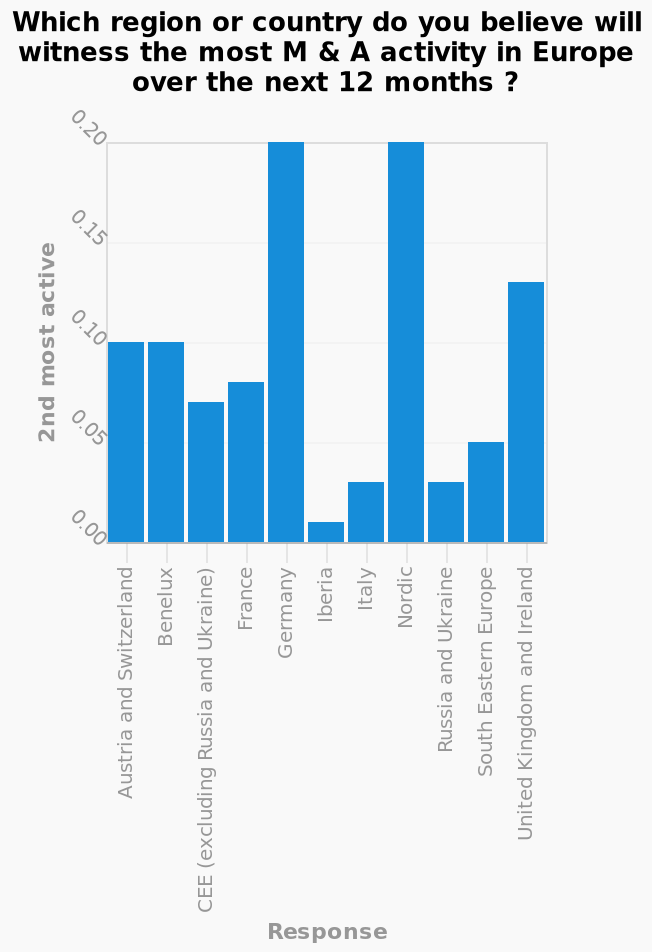<image>
What does the label "2nd most active" represent on the y-axis? The label "2nd most active" on the y-axis indicates the level of activity for the region or country that is expected to have the second-highest amount of M&A activity in Europe over the next 12 months. Does the label "2nd most active" on the y-axis indicate the level of activity for the region or country that is expected to have the highest amount of M&A activity in Europe over the next 12 months? No.The label "2nd most active" on the y-axis indicates the level of activity for the region or country that is expected to have the second-highest amount of M&A activity in Europe over the next 12 months. 